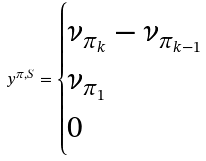Convert formula to latex. <formula><loc_0><loc_0><loc_500><loc_500>y ^ { \pi , S } = \begin{cases} \nu _ { \pi _ { k } } - \nu _ { \pi _ { k - 1 } } & \\ \nu _ { \pi _ { 1 } } & \\ 0 & \end{cases}</formula> 